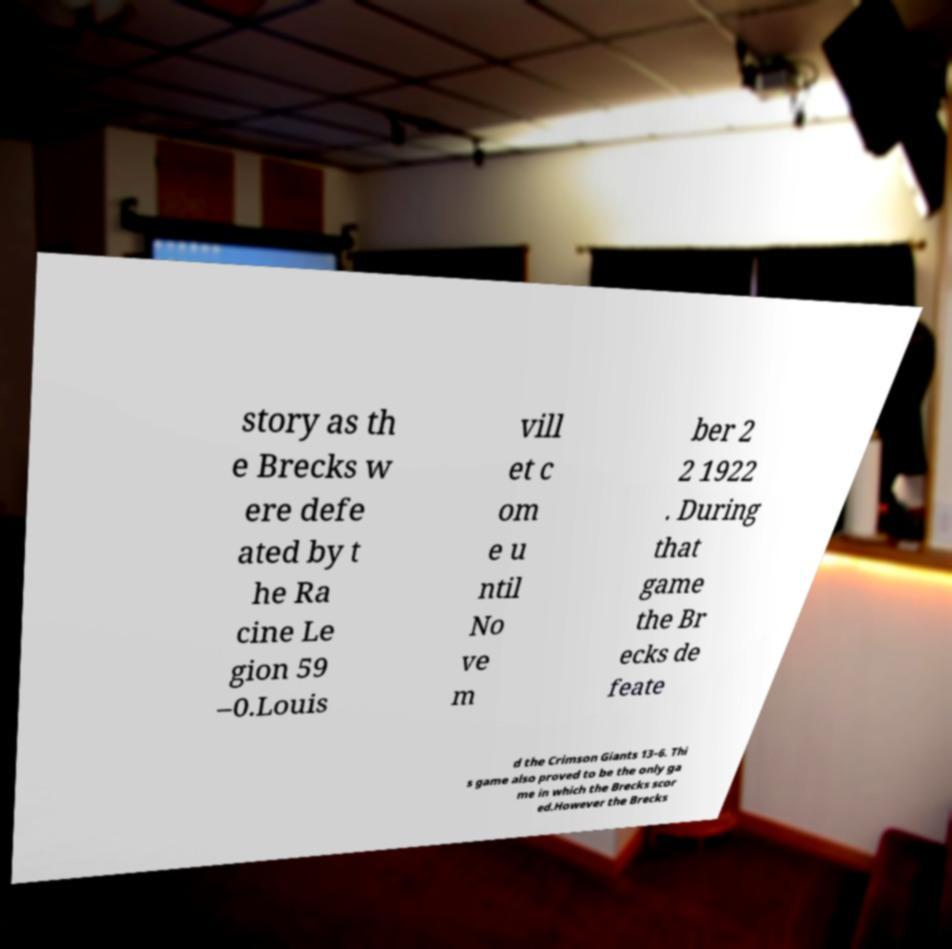Please read and relay the text visible in this image. What does it say? story as th e Brecks w ere defe ated by t he Ra cine Le gion 59 –0.Louis vill et c om e u ntil No ve m ber 2 2 1922 . During that game the Br ecks de feate d the Crimson Giants 13–6. Thi s game also proved to be the only ga me in which the Brecks scor ed.However the Brecks 